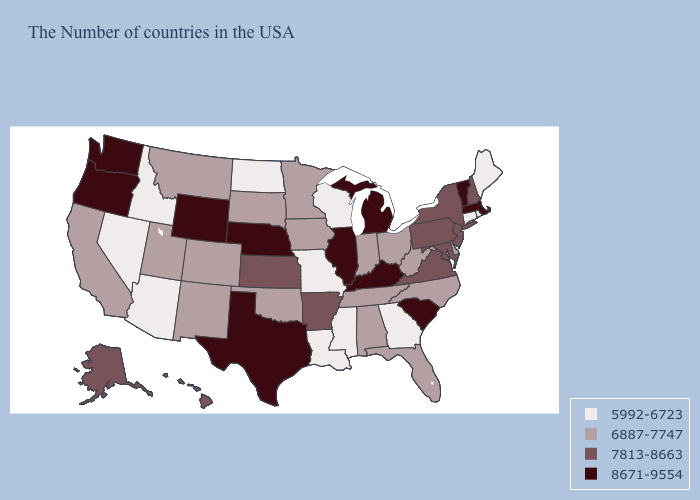Is the legend a continuous bar?
Answer briefly. No. Does the map have missing data?
Quick response, please. No. Does Oregon have the highest value in the West?
Quick response, please. Yes. Does South Dakota have the lowest value in the USA?
Write a very short answer. No. Among the states that border Florida , does Alabama have the highest value?
Keep it brief. Yes. What is the value of Arkansas?
Be succinct. 7813-8663. Among the states that border Texas , does Oklahoma have the lowest value?
Be succinct. No. What is the value of Nevada?
Be succinct. 5992-6723. What is the value of Kansas?
Write a very short answer. 7813-8663. Which states have the lowest value in the USA?
Quick response, please. Maine, Rhode Island, Connecticut, Georgia, Wisconsin, Mississippi, Louisiana, Missouri, North Dakota, Arizona, Idaho, Nevada. Which states hav the highest value in the West?
Answer briefly. Wyoming, Washington, Oregon. Does New Jersey have the highest value in the USA?
Answer briefly. No. What is the highest value in the USA?
Write a very short answer. 8671-9554. Does Virginia have a lower value than Vermont?
Give a very brief answer. Yes. What is the value of North Carolina?
Short answer required. 6887-7747. 